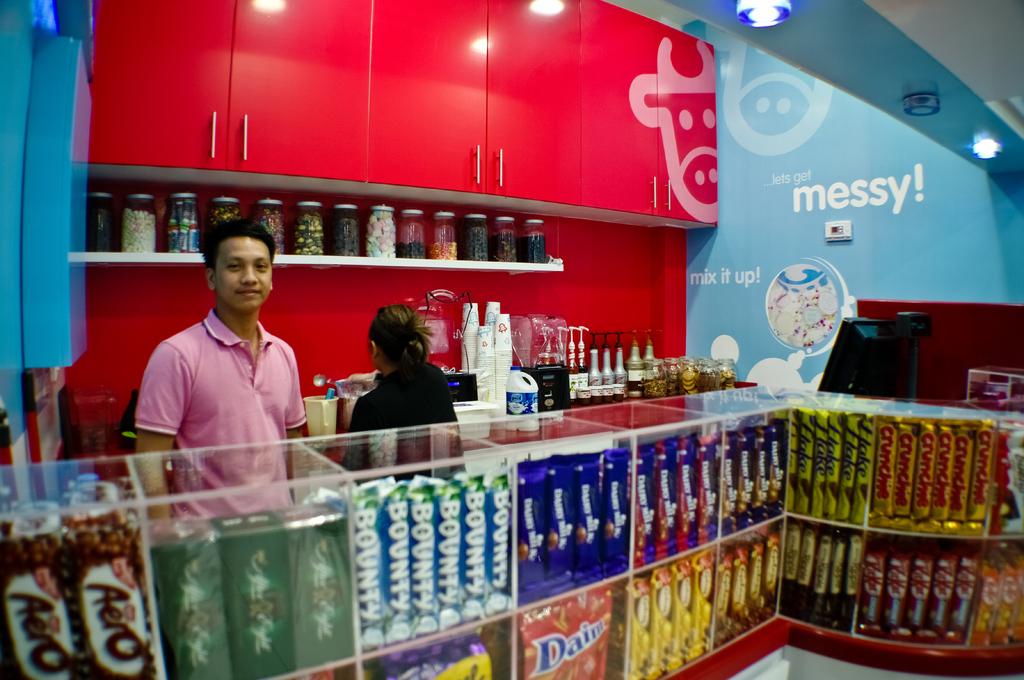What brand is directly in front of the man in the pink shirt?
Offer a very short reply. Bounty. 